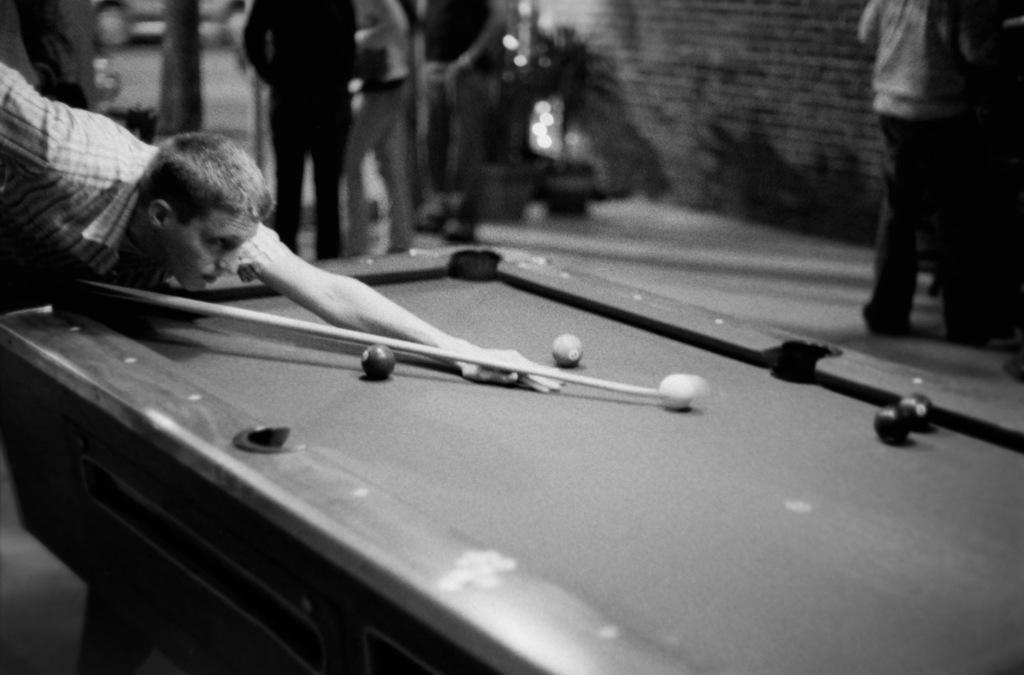What activity is the person in the image engaged in? The person in the image is playing the game snooker. Are there any other people present in the image? Yes, there are people standing at the back in the image. What can be seen behind the people in the image? There is a wall in the back of the image. What flavor of ice cream is the giraffe eating in the image? There is no giraffe or ice cream present in the image. 